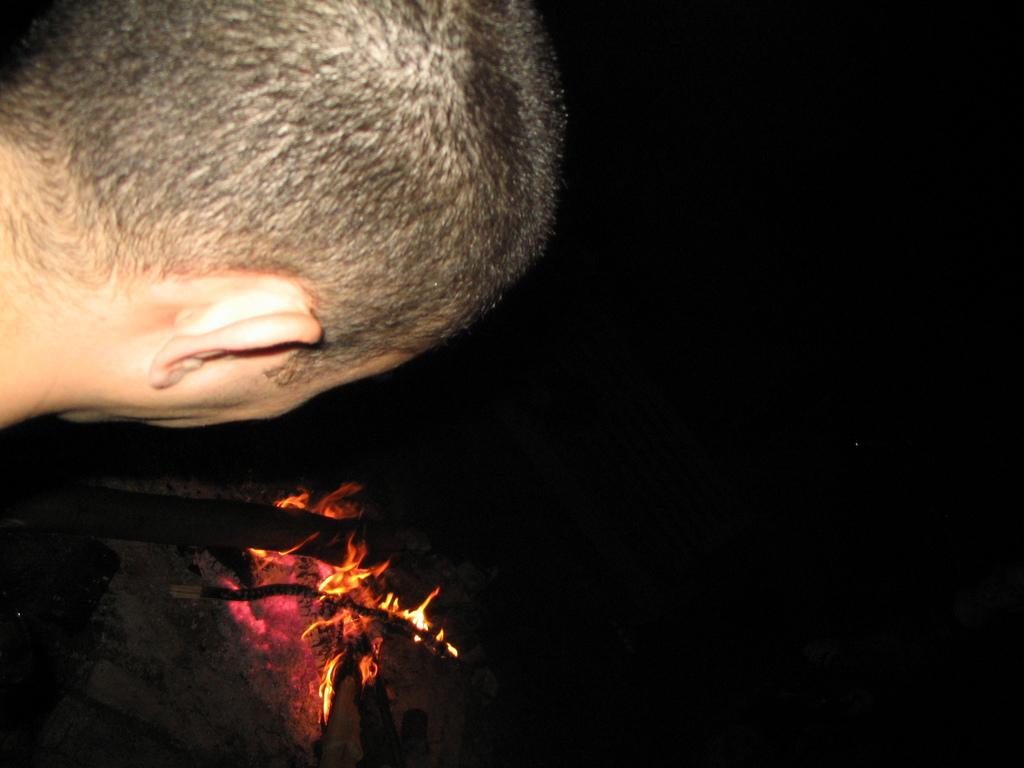In one or two sentences, can you explain what this image depicts? In this image in the front there is a person. In the center there is a bonfire. 